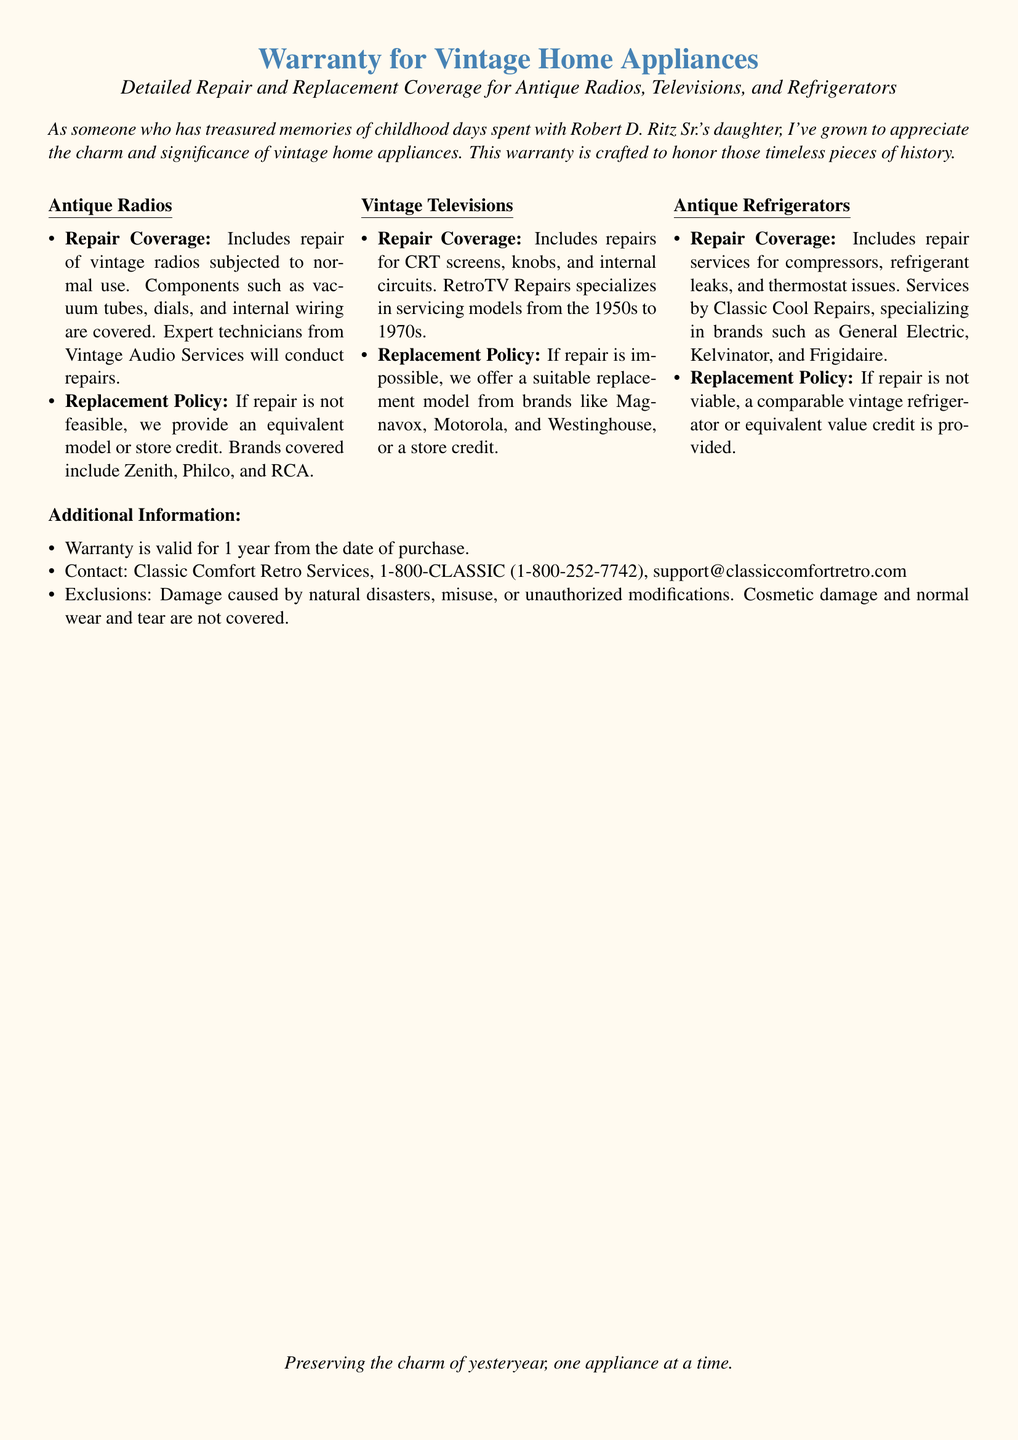what types of appliances are covered? The document specifies that it covers antique radios, vintage televisions, and antique refrigerators.
Answer: antique radios, vintage televisions, antique refrigerators who conducts repairs for vintage radios? The document states that repairs for vintage radios are conducted by Vintage Audio Services.
Answer: Vintage Audio Services what is the warranty duration? The warranty is valid for 1 year from the date of purchase.
Answer: 1 year which brand is not included in the repair coverage? The document does not mention any excluded brands in the repair coverage, but specifically lists covered brands: Zenith, Philco, and RCA.
Answer: None what is provided if repair of a refrigerant is not possible? The document states that a comparable vintage refrigerator or equivalent value credit is provided if repair is not viable.
Answer: comparable vintage refrigerator or equivalent value credit how can I contact customer support? The document provides the contact number and email for customer support.
Answer: 1-800-CLASSIC, support@classiccomfortretro.com what type of damage is excluded from the warranty? The document lists exclusions, including damage caused by natural disasters, misuse, or unauthorized modifications.
Answer: natural disasters, misuse, or unauthorized modifications which service specializes in vintage televisions? The document mentions that RetroTV Repairs specializes in servicing vintage televisions.
Answer: RetroTV Repairs 